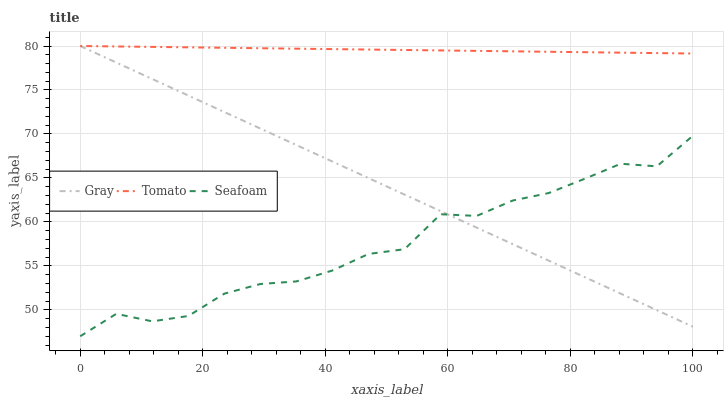Does Seafoam have the minimum area under the curve?
Answer yes or no. Yes. Does Tomato have the maximum area under the curve?
Answer yes or no. Yes. Does Gray have the minimum area under the curve?
Answer yes or no. No. Does Gray have the maximum area under the curve?
Answer yes or no. No. Is Gray the smoothest?
Answer yes or no. Yes. Is Seafoam the roughest?
Answer yes or no. Yes. Is Seafoam the smoothest?
Answer yes or no. No. Is Gray the roughest?
Answer yes or no. No. Does Seafoam have the lowest value?
Answer yes or no. Yes. Does Gray have the lowest value?
Answer yes or no. No. Does Gray have the highest value?
Answer yes or no. Yes. Does Seafoam have the highest value?
Answer yes or no. No. Is Seafoam less than Tomato?
Answer yes or no. Yes. Is Tomato greater than Seafoam?
Answer yes or no. Yes. Does Gray intersect Tomato?
Answer yes or no. Yes. Is Gray less than Tomato?
Answer yes or no. No. Is Gray greater than Tomato?
Answer yes or no. No. Does Seafoam intersect Tomato?
Answer yes or no. No. 